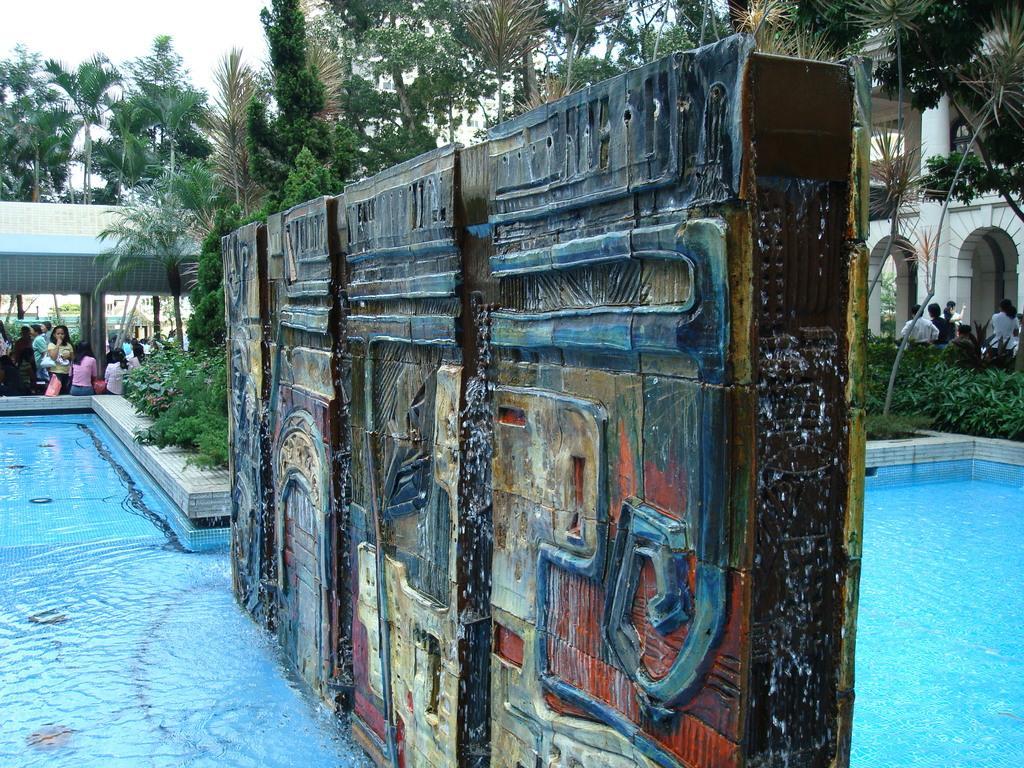Could you give a brief overview of what you see in this image? In this picture there is a wooden box on the swimming pool. On the left we can see the group of persons who are sitting near to the swimming pool and plants. On the right there is a building. In front of the building we can see the group of persons who are standing under the tree. In the background we can see many buildings and trees. At the top there is a sky. 